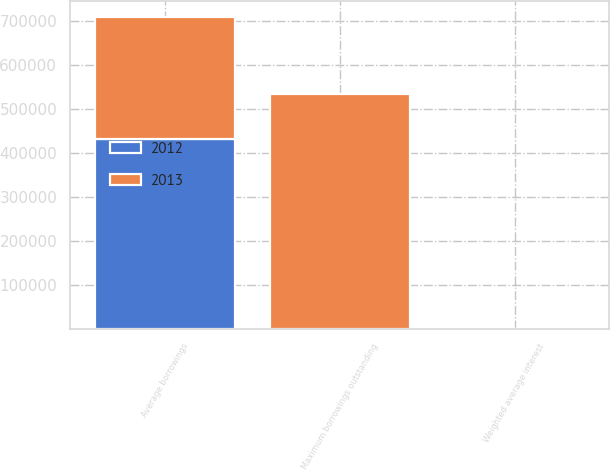Convert chart. <chart><loc_0><loc_0><loc_500><loc_500><stacked_bar_chart><ecel><fcel>Average borrowings<fcel>Maximum borrowings outstanding<fcel>Weighted average interest<nl><fcel>2012<fcel>432064<fcel>0.49<fcel>0.36<nl><fcel>2013<fcel>277952<fcel>534700<fcel>0.46<nl></chart> 